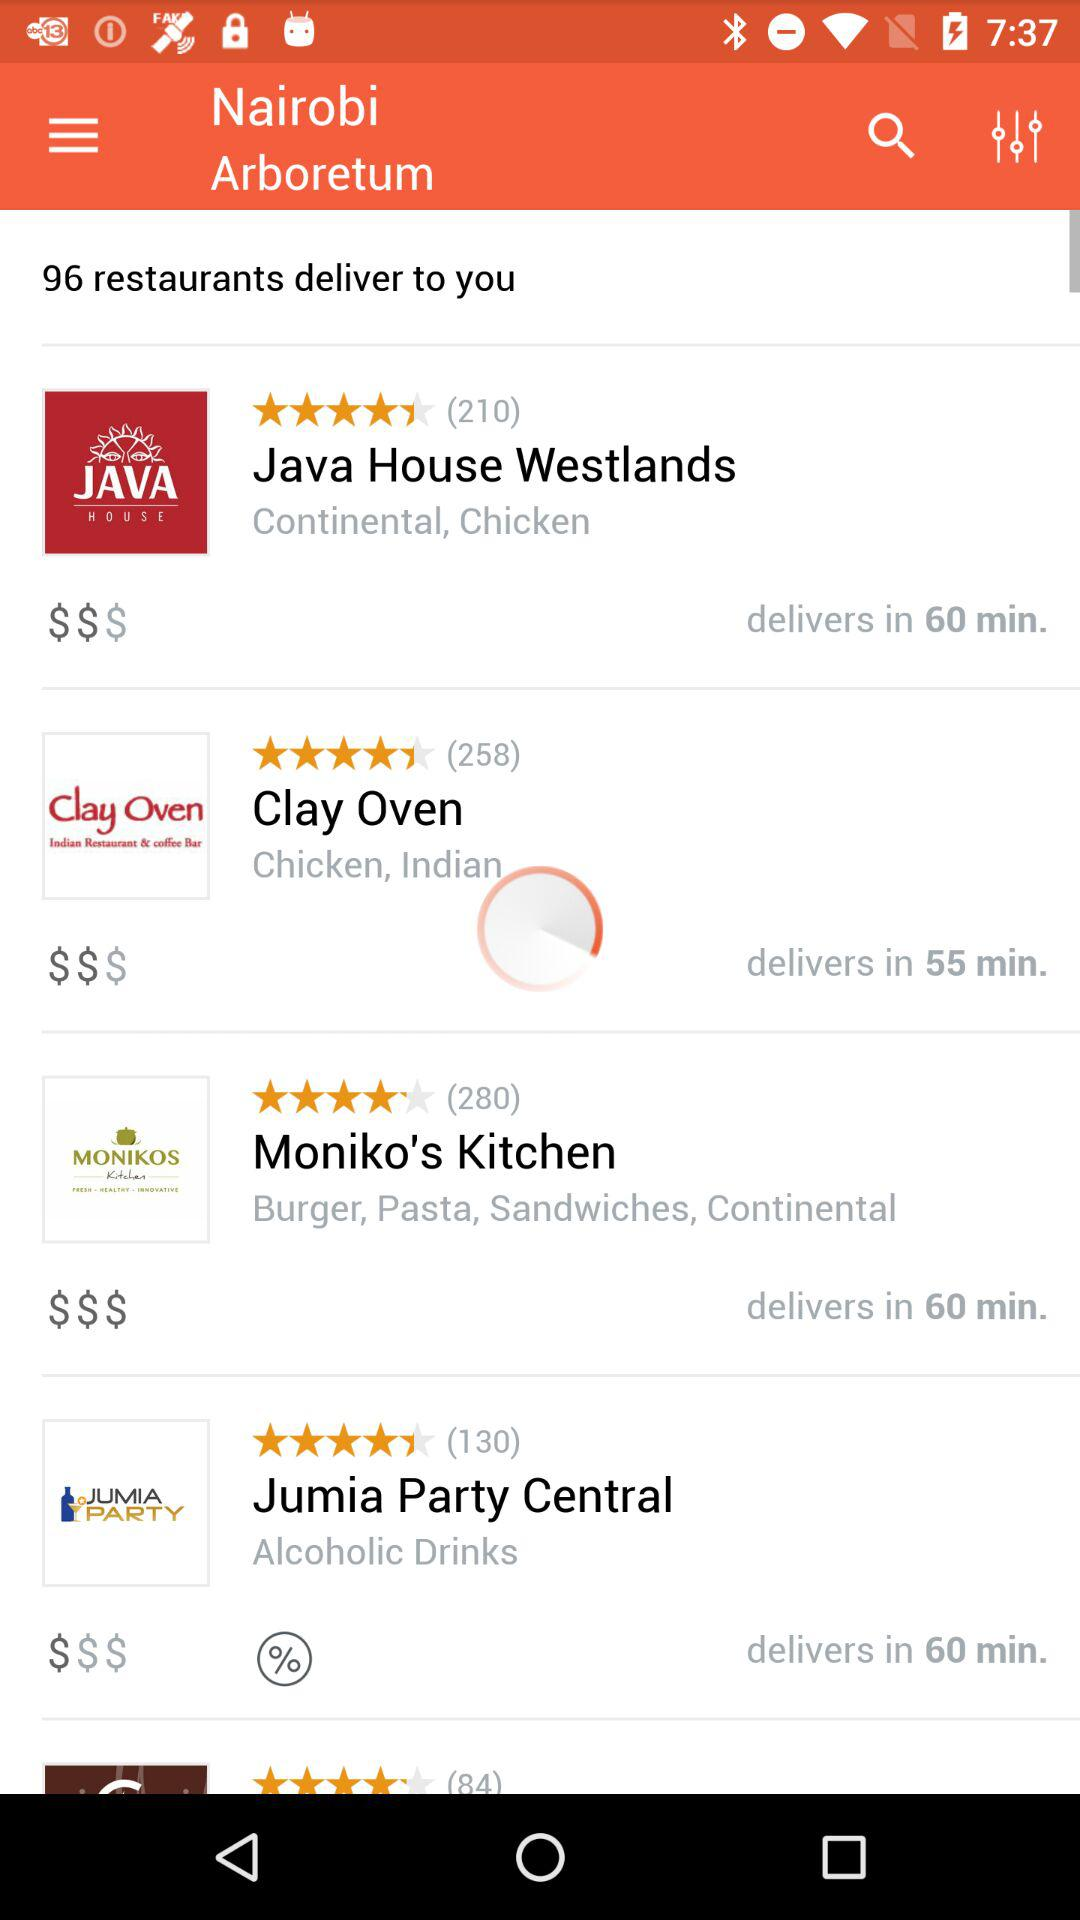What restaurant serves alcoholic drinks? The restaurant that serves alcoholic drinks is Jumia Party Central. 